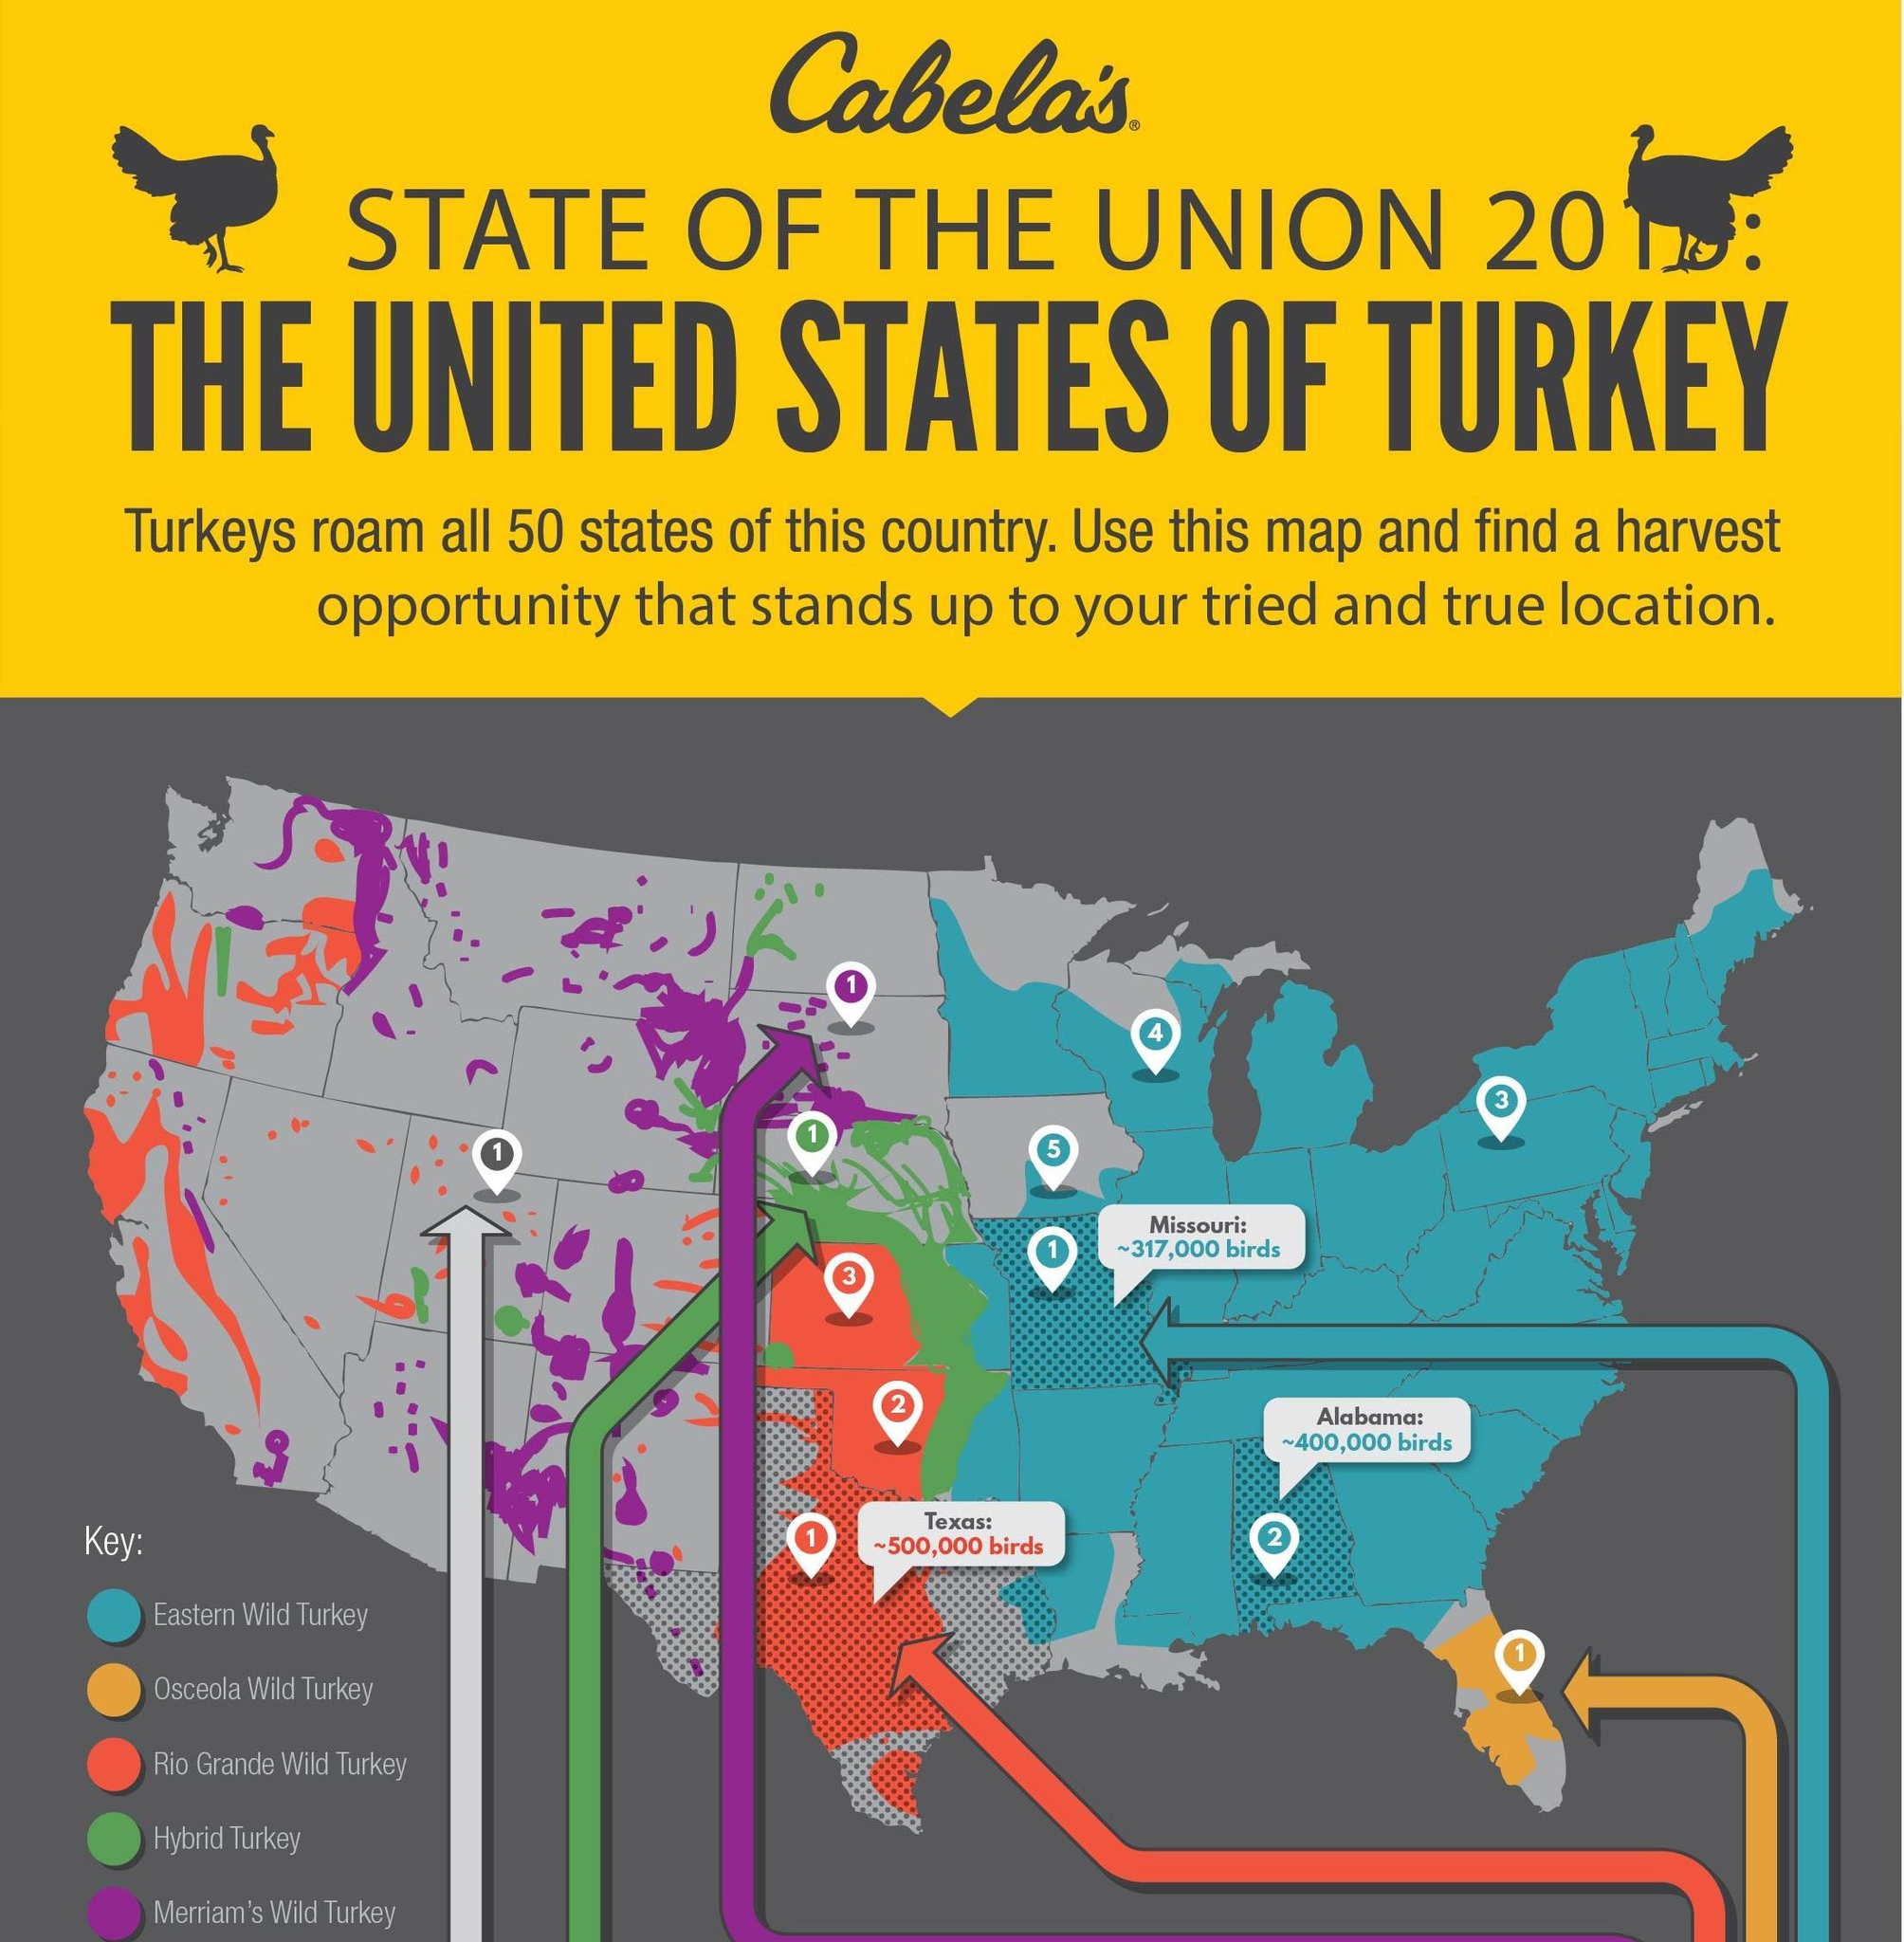How many different types of turkeys are mentioned in the key?
Answer the question with a short phrase. 5 Orange color is used to represent which type of turkey? Osceola Wild Turkey Which color covers a major area of the map - red, orange, blue or green? blue As per the map, which type of turkey is found in a major area of the country? Eastern Wild Turkey The Rio Grande Wild Turkey is represented by which color - red, orange, blue or green? red 